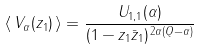Convert formula to latex. <formula><loc_0><loc_0><loc_500><loc_500>\left \langle \, V _ { \alpha } ( z _ { 1 } ) \, \right \rangle = \frac { U _ { 1 , 1 } ( \alpha ) } { ( 1 - z _ { 1 } \bar { z } _ { 1 } ) ^ { \, 2 \alpha ( Q - \alpha ) } }</formula> 